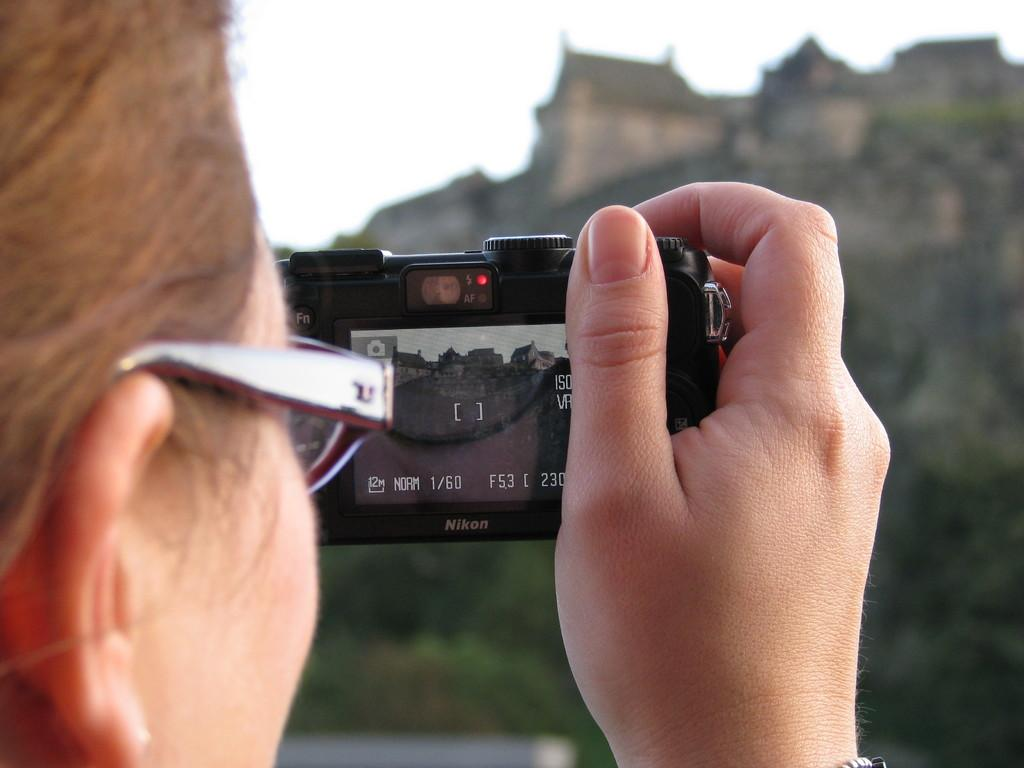What is the person in the image doing? The person is holding a camera and clicking pictures. What type of view is visible in the image? The image appears to be a scenic viewic view. What can be seen in the background of the image? There are buildings in the background of the image. Where are the buildings located in relation to the hill? The buildings are at the top of a hill. What type of health advice can be seen written on the pail in the image? There is no pail present in the image, and therefore no health advice can be seen. 